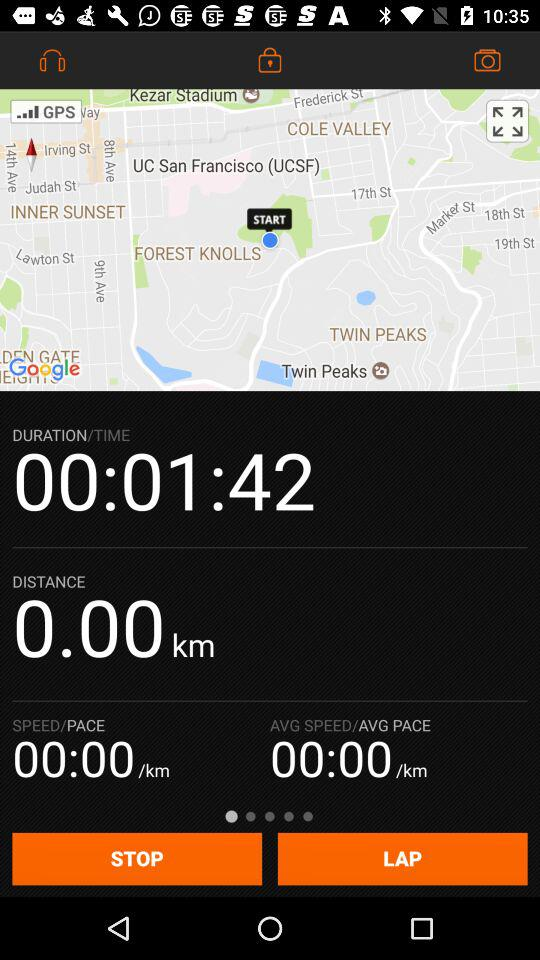What's the distance? The distance is 0.00 km. 